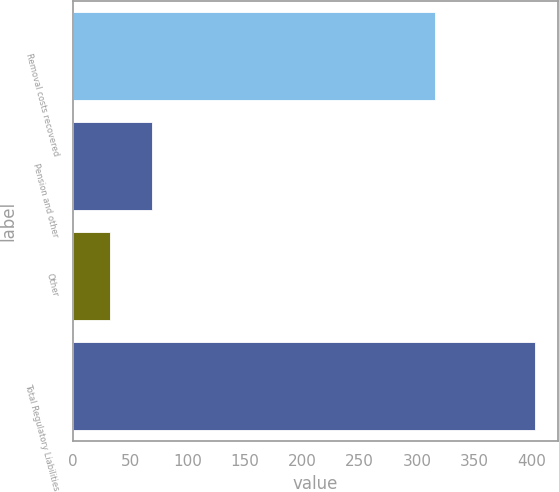Convert chart to OTSL. <chart><loc_0><loc_0><loc_500><loc_500><bar_chart><fcel>Removal costs recovered<fcel>Pension and other<fcel>Other<fcel>Total Regulatory Liabilities<nl><fcel>316<fcel>69.1<fcel>32<fcel>403<nl></chart> 